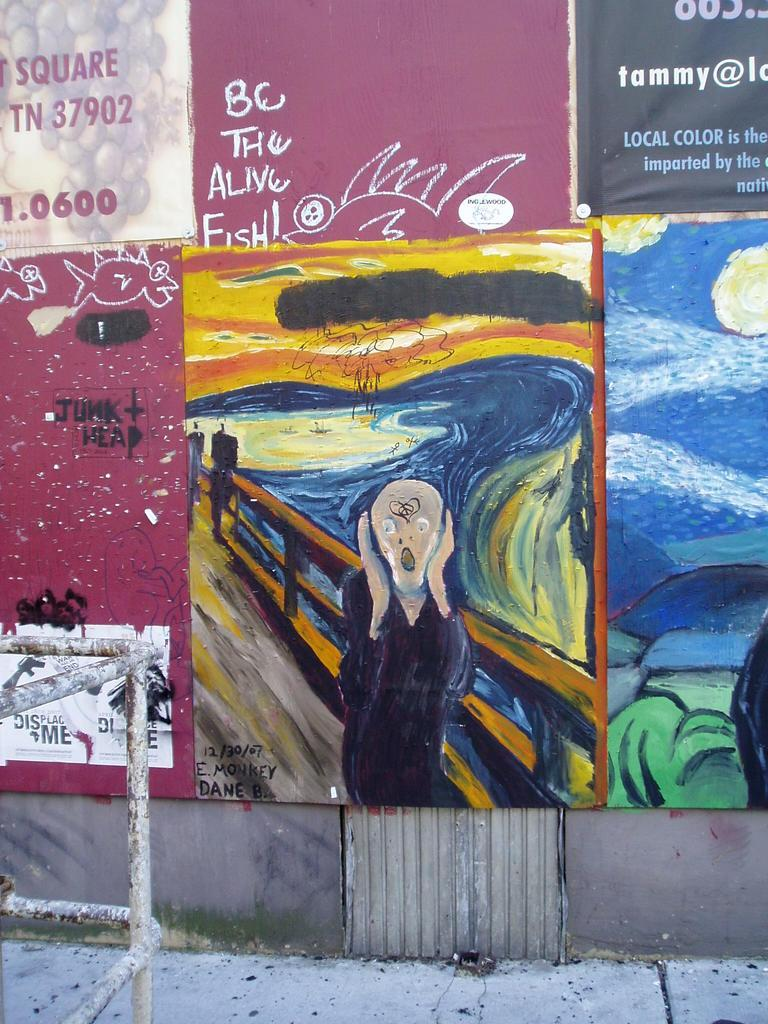<image>
Relay a brief, clear account of the picture shown. Outdoor art plastered upon a wall with one poster entitled The Alive Fish. 